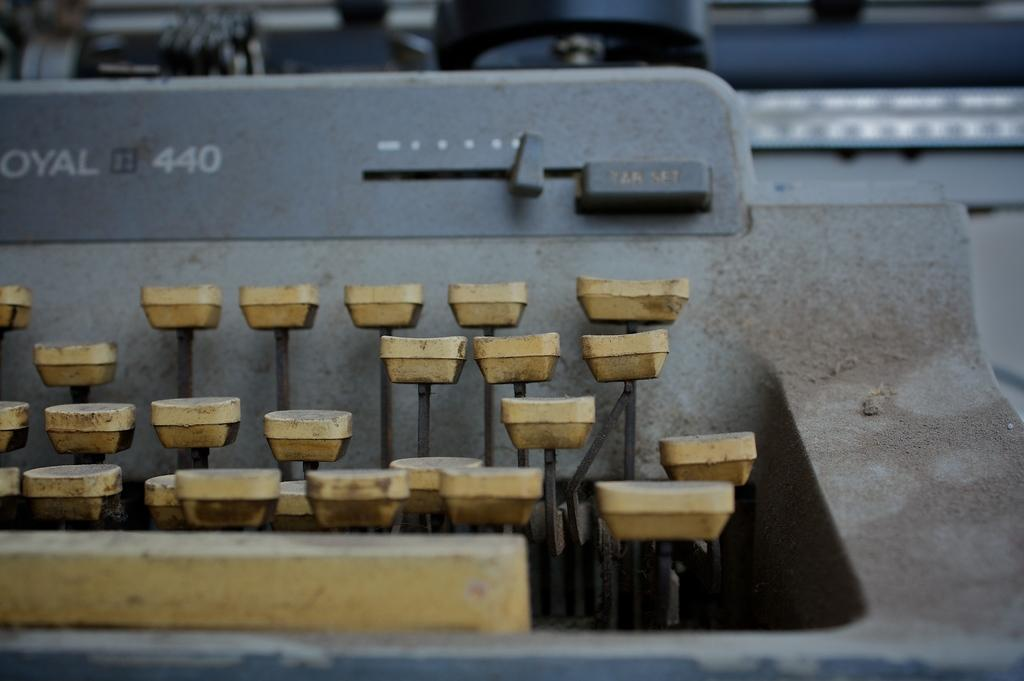<image>
Present a compact description of the photo's key features. A battered and filthy Royal 440 manual typewriter. 